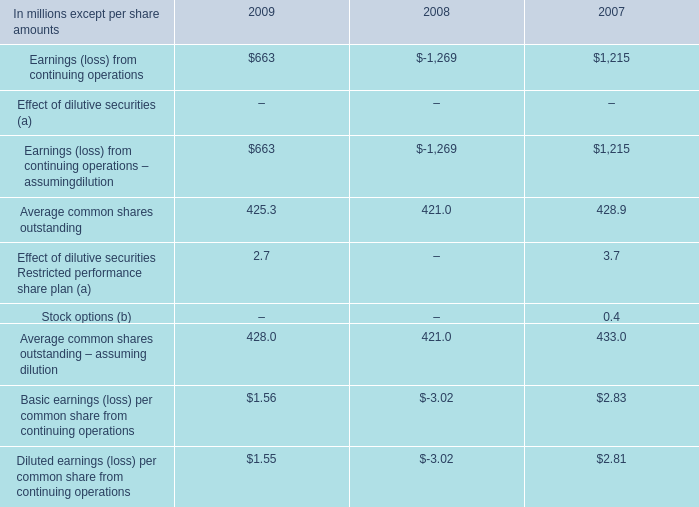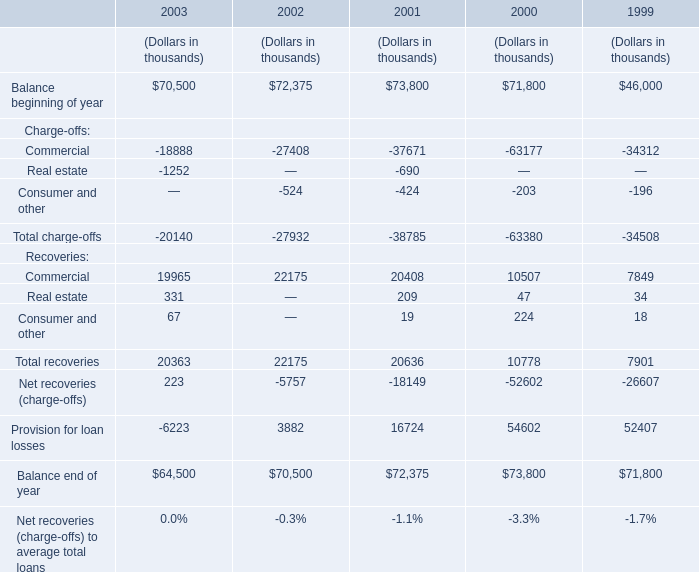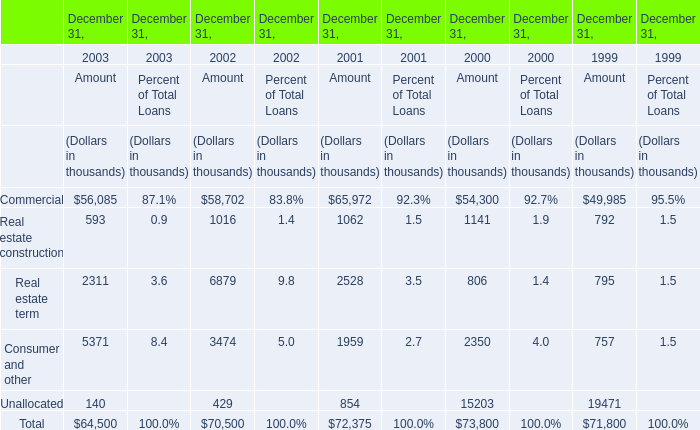What was the average of the Commercial for Recoveries in the years where Balance beginning of year is positive? (in thousand) 
Computations: (((((19965 + 22175) + 20408) + 10507) + 7849) / 5)
Answer: 16180.8. 